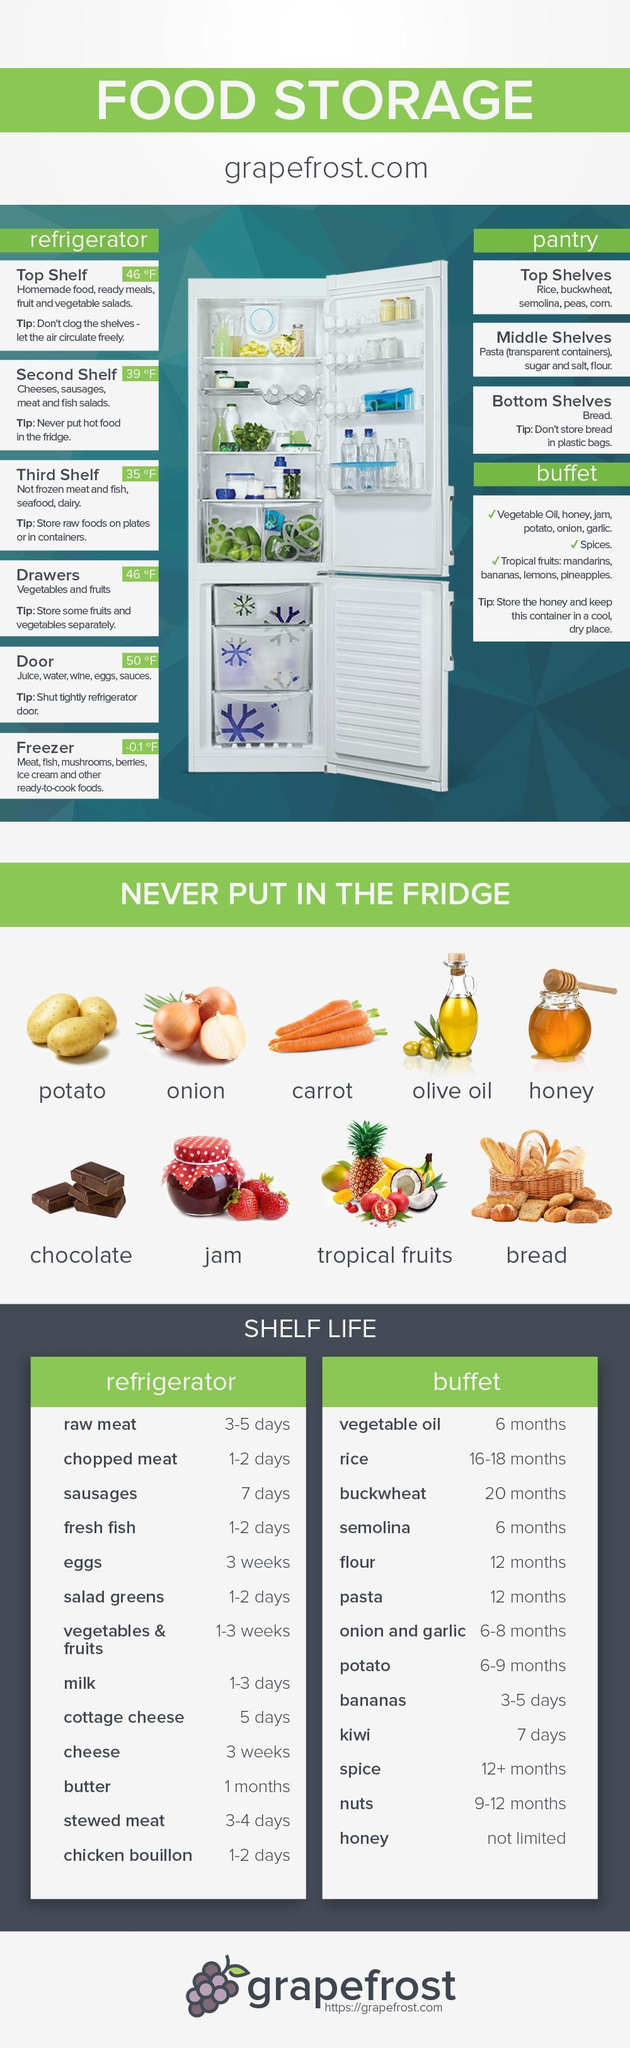Which fruit has higher shelf life - banana or kiwi?
Answer the question with a short phrase. kiwi Where should rice, semolina, buckwheat etc be stored - pantry or refrigerator? pantry Which of the dairy products listed has the highest shelf life? butter Where in the fridge should fruits and vegetables be kept? drawers On which shelf should cheese, sausage, meat and fish salad be stored? second shelf Which vegetables are stored in the buffet? potato, onion, garlic Which food grain stored in buffet has highest shelf life? buckwheat Where are eggs stored - pantry or refrigerator? refrigerator Where in the pantry should bread be stored? Bottom shelves Which type of fruits should never be stored in the refrigerator? tropical fruits 